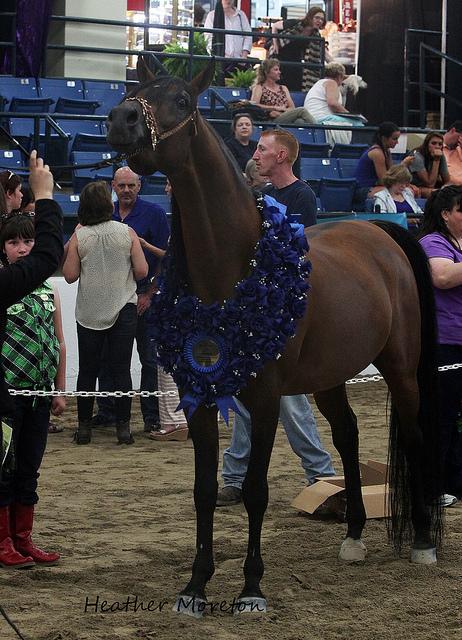What color is on the nose of the horse facing camera?
Be succinct. Black. What is the horse wearing?
Write a very short answer. Blue ribbon. What animals are shown?
Write a very short answer. Horse. What are the bleachers used for?
Give a very brief answer. Spectators. What are the people riding?
Answer briefly. Horse. What is the name of this photographer?
Write a very short answer. Heather moreton. 